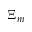Convert formula to latex. <formula><loc_0><loc_0><loc_500><loc_500>\Xi _ { m }</formula> 